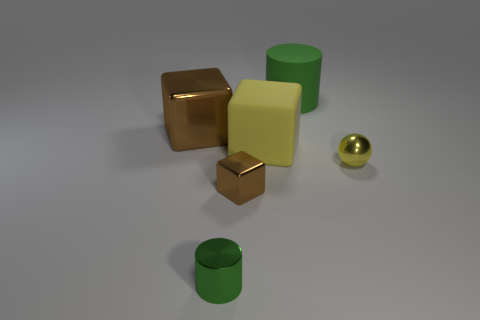Are there any brown metallic things of the same size as the ball?
Provide a succinct answer. Yes. There is a cylinder that is to the left of the big green cylinder; does it have the same color as the small shiny sphere?
Keep it short and to the point. No. How many gray objects are tiny metal blocks or tiny balls?
Provide a short and direct response. 0. How many other cubes are the same color as the small block?
Make the answer very short. 1. Is the large green object made of the same material as the yellow block?
Offer a terse response. Yes. There is a large cylinder that is on the right side of the tiny green object; how many balls are behind it?
Provide a short and direct response. 0. Is the rubber cylinder the same size as the green metal thing?
Offer a terse response. No. What number of objects have the same material as the tiny yellow sphere?
Give a very brief answer. 3. The other matte object that is the same shape as the tiny brown object is what size?
Your answer should be compact. Large. There is a big object in front of the large brown thing; is its shape the same as the tiny brown thing?
Your answer should be very brief. Yes. 